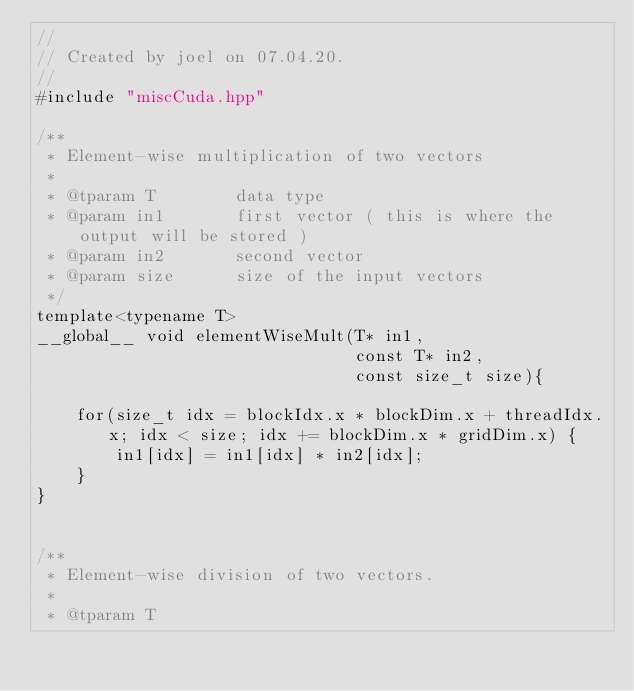<code> <loc_0><loc_0><loc_500><loc_500><_Cuda_>//
// Created by joel on 07.04.20.
//
#include "miscCuda.hpp"

/**
 * Element-wise multiplication of two vectors
 *
 * @tparam T        data type
 * @param in1       first vector ( this is where the output will be stored )
 * @param in2       second vector
 * @param size      size of the input vectors
 */
template<typename T>
__global__ void elementWiseMult(T* in1,
                                const T* in2,
                                const size_t size){

    for(size_t idx = blockIdx.x * blockDim.x + threadIdx.x; idx < size; idx += blockDim.x * gridDim.x) {
        in1[idx] = in1[idx] * in2[idx];
    }
}


/**
 * Element-wise division of two vectors.
 *
 * @tparam T</code> 